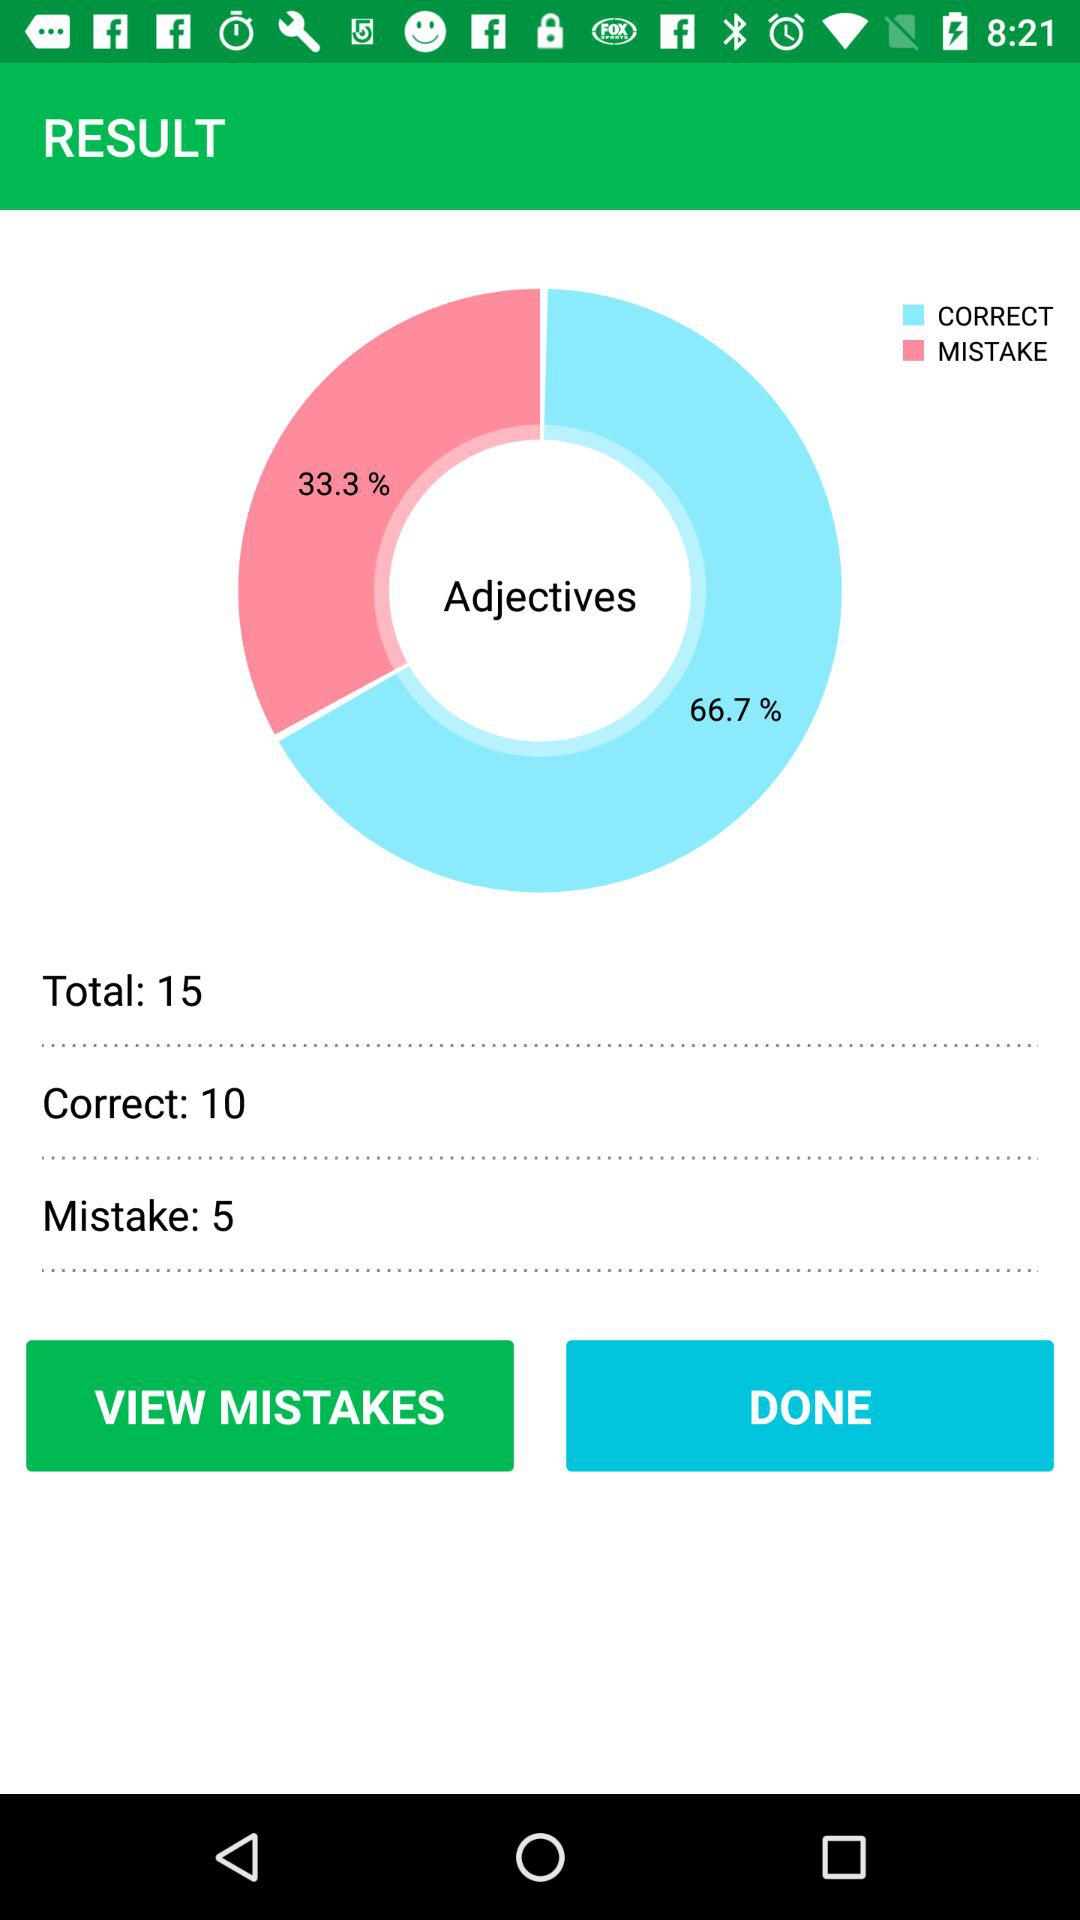What is the total number of adjective questions? The total number of adjective questions is 15. 